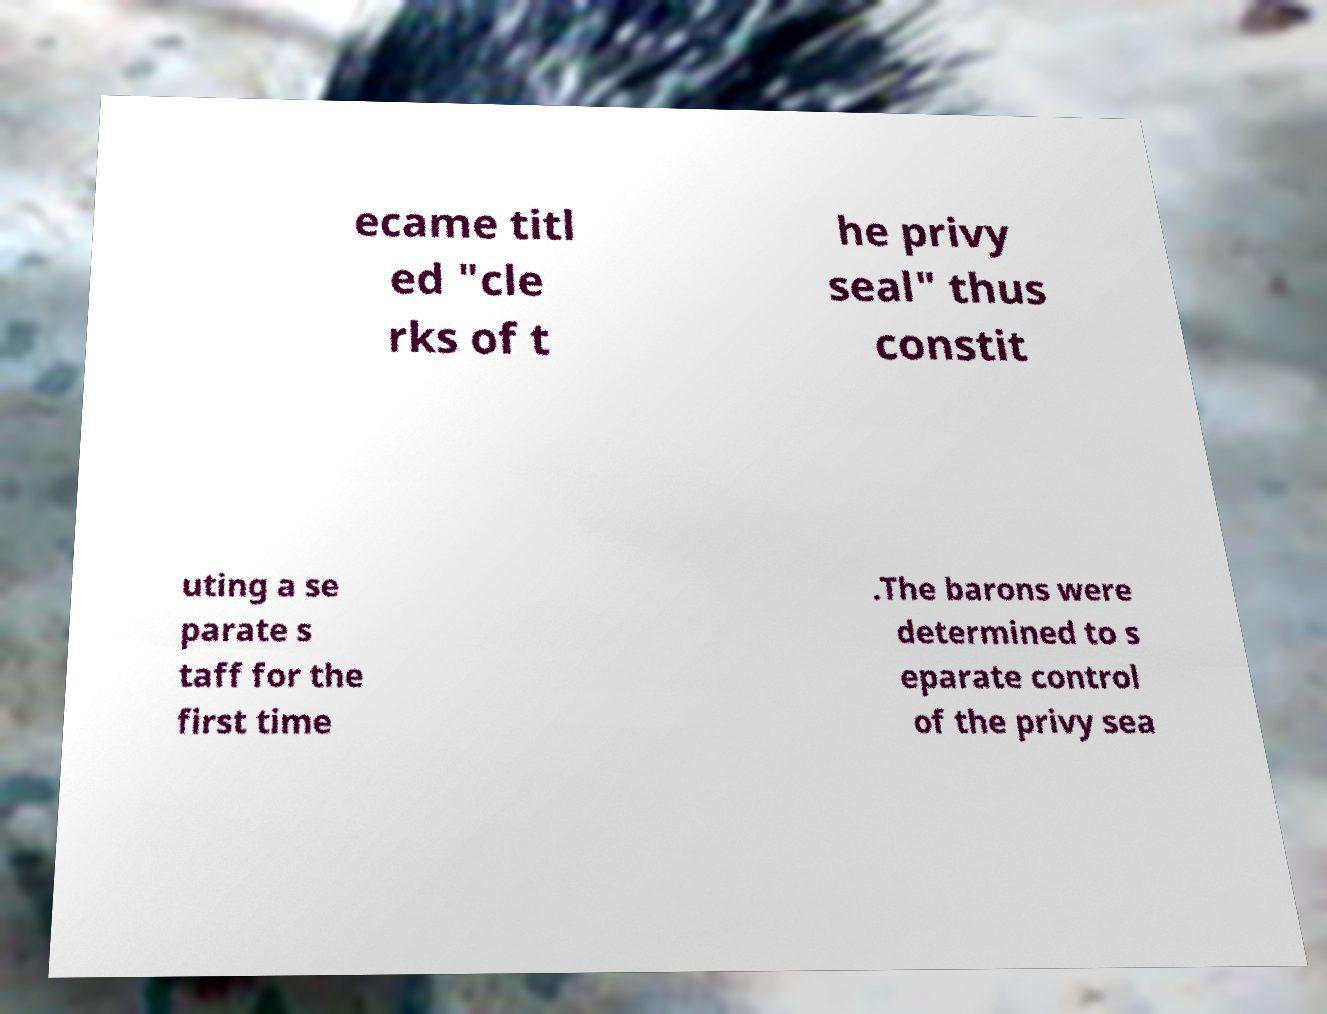Can you read and provide the text displayed in the image?This photo seems to have some interesting text. Can you extract and type it out for me? ecame titl ed "cle rks of t he privy seal" thus constit uting a se parate s taff for the first time .The barons were determined to s eparate control of the privy sea 